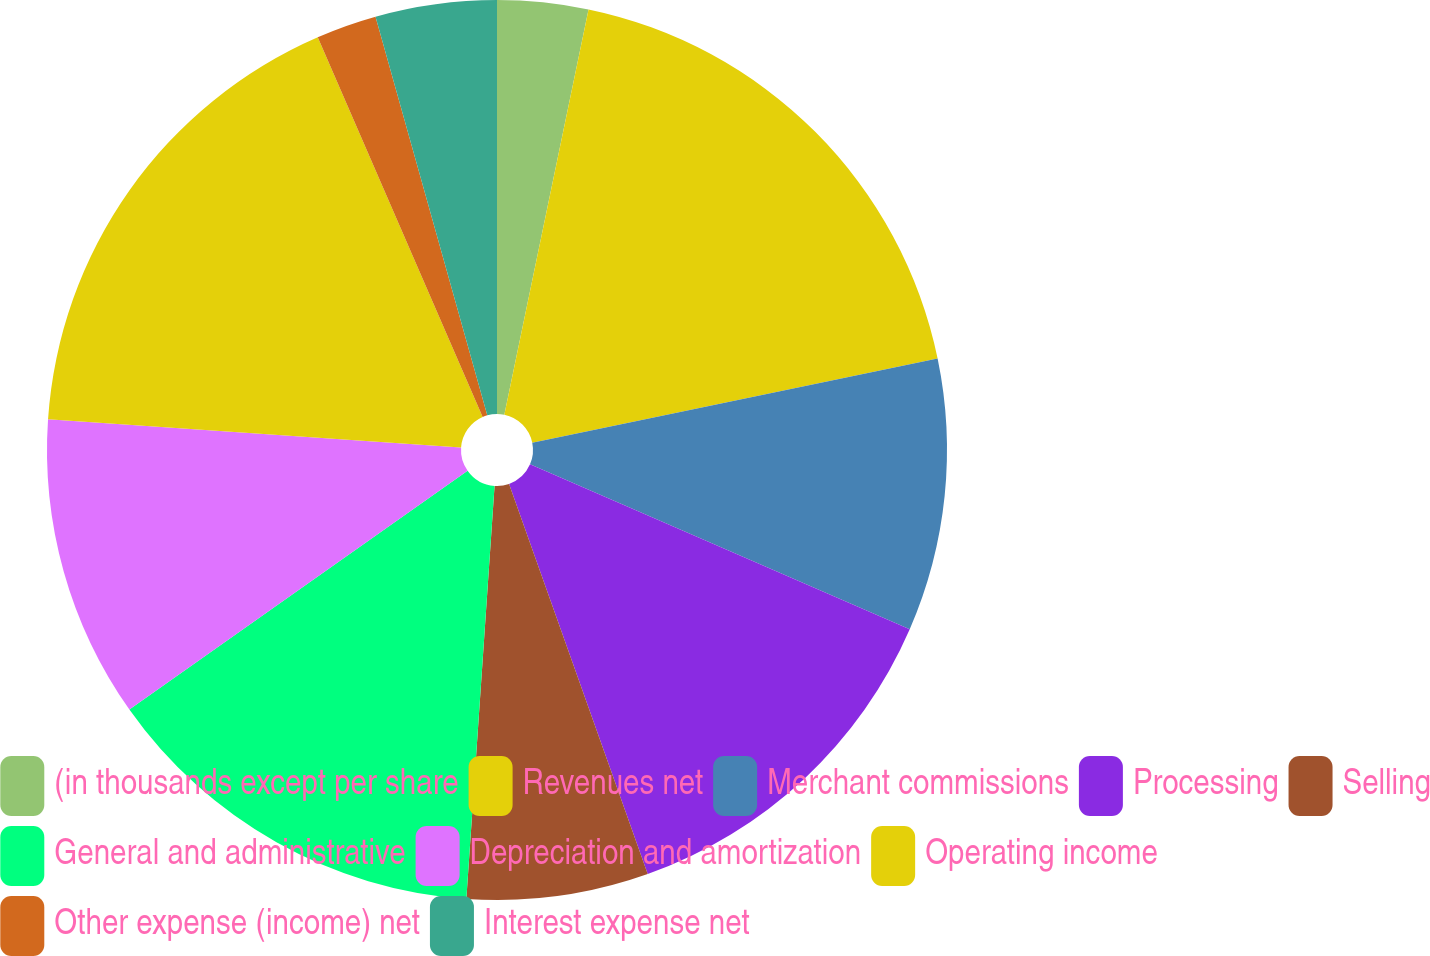<chart> <loc_0><loc_0><loc_500><loc_500><pie_chart><fcel>(in thousands except per share<fcel>Revenues net<fcel>Merchant commissions<fcel>Processing<fcel>Selling<fcel>General and administrative<fcel>Depreciation and amortization<fcel>Operating income<fcel>Other expense (income) net<fcel>Interest expense net<nl><fcel>3.26%<fcel>18.48%<fcel>9.78%<fcel>13.04%<fcel>6.52%<fcel>14.13%<fcel>10.87%<fcel>17.39%<fcel>2.17%<fcel>4.35%<nl></chart> 